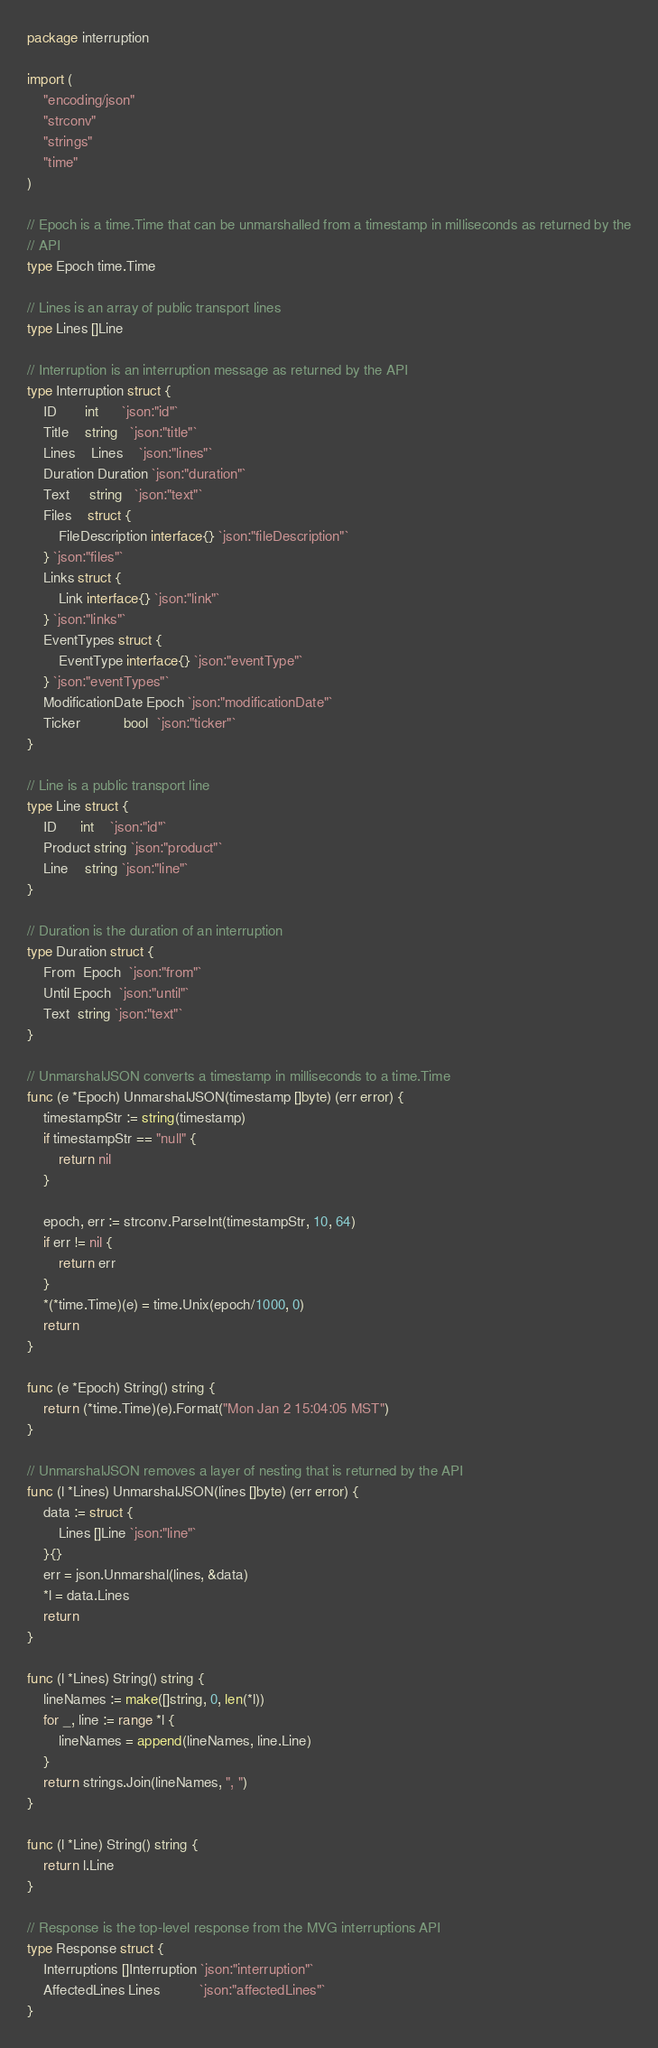Convert code to text. <code><loc_0><loc_0><loc_500><loc_500><_Go_>package interruption

import (
	"encoding/json"
	"strconv"
	"strings"
	"time"
)

// Epoch is a time.Time that can be unmarshalled from a timestamp in milliseconds as returned by the
// API
type Epoch time.Time

// Lines is an array of public transport lines
type Lines []Line

// Interruption is an interruption message as returned by the API
type Interruption struct {
	ID       int      `json:"id"`
	Title    string   `json:"title"`
	Lines    Lines    `json:"lines"`
	Duration Duration `json:"duration"`
	Text     string   `json:"text"`
	Files    struct {
		FileDescription interface{} `json:"fileDescription"`
	} `json:"files"`
	Links struct {
		Link interface{} `json:"link"`
	} `json:"links"`
	EventTypes struct {
		EventType interface{} `json:"eventType"`
	} `json:"eventTypes"`
	ModificationDate Epoch `json:"modificationDate"`
	Ticker           bool  `json:"ticker"`
}

// Line is a public transport line
type Line struct {
	ID      int    `json:"id"`
	Product string `json:"product"`
	Line    string `json:"line"`
}

// Duration is the duration of an interruption
type Duration struct {
	From  Epoch  `json:"from"`
	Until Epoch  `json:"until"`
	Text  string `json:"text"`
}

// UnmarshalJSON converts a timestamp in milliseconds to a time.Time
func (e *Epoch) UnmarshalJSON(timestamp []byte) (err error) {
	timestampStr := string(timestamp)
	if timestampStr == "null" {
		return nil
	}

	epoch, err := strconv.ParseInt(timestampStr, 10, 64)
	if err != nil {
		return err
	}
	*(*time.Time)(e) = time.Unix(epoch/1000, 0)
	return
}

func (e *Epoch) String() string {
	return (*time.Time)(e).Format("Mon Jan 2 15:04:05 MST")
}

// UnmarshalJSON removes a layer of nesting that is returned by the API
func (l *Lines) UnmarshalJSON(lines []byte) (err error) {
	data := struct {
		Lines []Line `json:"line"`
	}{}
	err = json.Unmarshal(lines, &data)
	*l = data.Lines
	return
}

func (l *Lines) String() string {
	lineNames := make([]string, 0, len(*l))
	for _, line := range *l {
		lineNames = append(lineNames, line.Line)
	}
	return strings.Join(lineNames, ", ")
}

func (l *Line) String() string {
	return l.Line
}

// Response is the top-level response from the MVG interruptions API
type Response struct {
	Interruptions []Interruption `json:"interruption"`
	AffectedLines Lines          `json:"affectedLines"`
}
</code> 